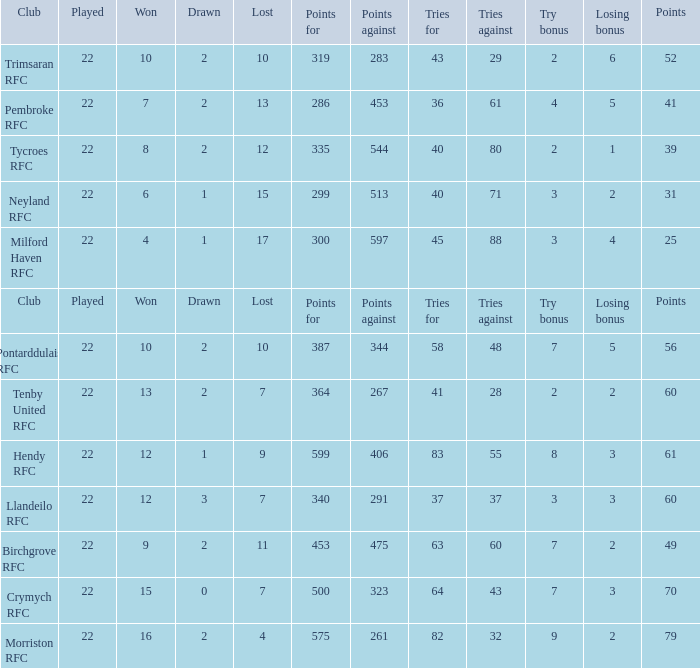Would you mind parsing the complete table? {'header': ['Club', 'Played', 'Won', 'Drawn', 'Lost', 'Points for', 'Points against', 'Tries for', 'Tries against', 'Try bonus', 'Losing bonus', 'Points'], 'rows': [['Trimsaran RFC', '22', '10', '2', '10', '319', '283', '43', '29', '2', '6', '52'], ['Pembroke RFC', '22', '7', '2', '13', '286', '453', '36', '61', '4', '5', '41'], ['Tycroes RFC', '22', '8', '2', '12', '335', '544', '40', '80', '2', '1', '39'], ['Neyland RFC', '22', '6', '1', '15', '299', '513', '40', '71', '3', '2', '31'], ['Milford Haven RFC', '22', '4', '1', '17', '300', '597', '45', '88', '3', '4', '25'], ['Club', 'Played', 'Won', 'Drawn', 'Lost', 'Points for', 'Points against', 'Tries for', 'Tries against', 'Try bonus', 'Losing bonus', 'Points'], ['Pontarddulais RFC', '22', '10', '2', '10', '387', '344', '58', '48', '7', '5', '56'], ['Tenby United RFC', '22', '13', '2', '7', '364', '267', '41', '28', '2', '2', '60'], ['Hendy RFC', '22', '12', '1', '9', '599', '406', '83', '55', '8', '3', '61'], ['Llandeilo RFC', '22', '12', '3', '7', '340', '291', '37', '37', '3', '3', '60'], ['Birchgrove RFC', '22', '9', '2', '11', '453', '475', '63', '60', '7', '2', '49'], ['Crymych RFC', '22', '15', '0', '7', '500', '323', '64', '43', '7', '3', '70'], ['Morriston RFC', '22', '16', '2', '4', '575', '261', '82', '32', '9', '2', '79']]}  how many points against with tries for being 43 1.0. 